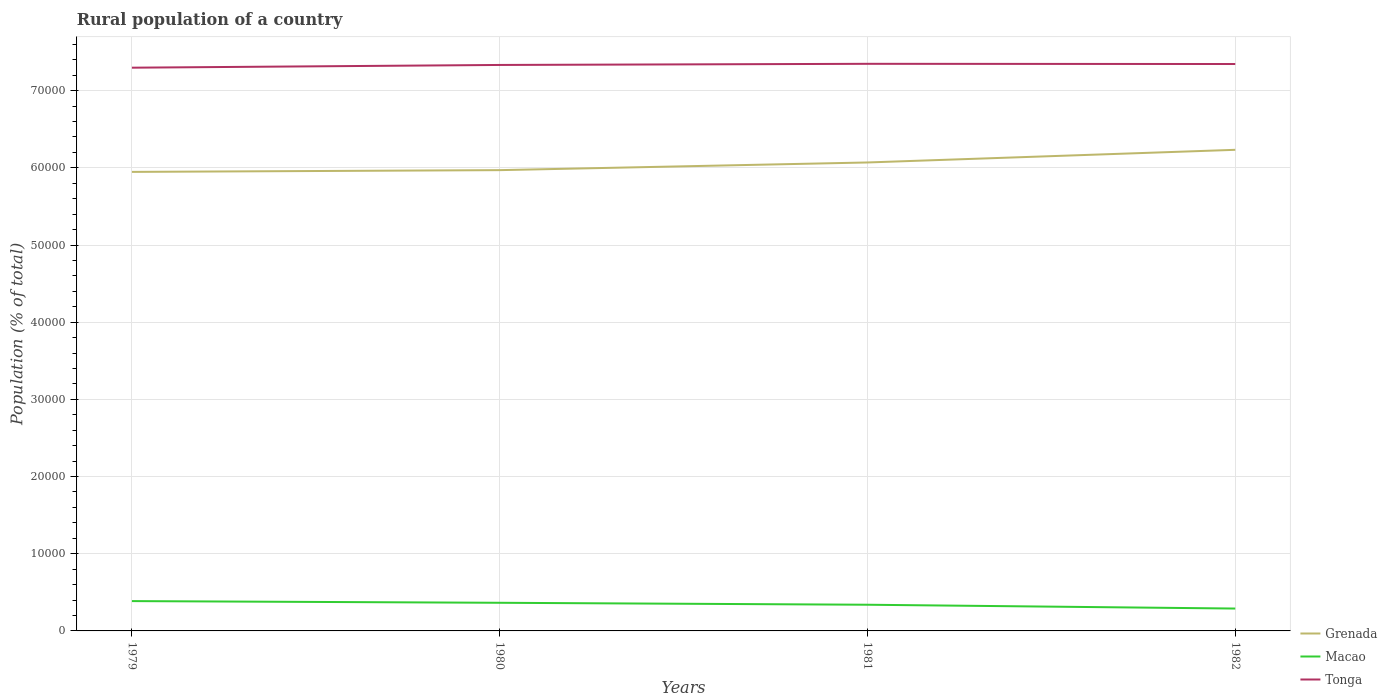Does the line corresponding to Macao intersect with the line corresponding to Tonga?
Provide a short and direct response. No. Is the number of lines equal to the number of legend labels?
Your response must be concise. Yes. Across all years, what is the maximum rural population in Grenada?
Provide a short and direct response. 5.95e+04. In which year was the rural population in Grenada maximum?
Your answer should be compact. 1979. What is the total rural population in Tonga in the graph?
Offer a terse response. -477. What is the difference between the highest and the second highest rural population in Grenada?
Your response must be concise. 2862. Does the graph contain grids?
Keep it short and to the point. Yes. Where does the legend appear in the graph?
Give a very brief answer. Bottom right. What is the title of the graph?
Provide a succinct answer. Rural population of a country. Does "Mongolia" appear as one of the legend labels in the graph?
Your answer should be compact. No. What is the label or title of the Y-axis?
Your answer should be very brief. Population (% of total). What is the Population (% of total) of Grenada in 1979?
Ensure brevity in your answer.  5.95e+04. What is the Population (% of total) of Macao in 1979?
Provide a short and direct response. 3865. What is the Population (% of total) in Tonga in 1979?
Your answer should be very brief. 7.30e+04. What is the Population (% of total) in Grenada in 1980?
Provide a succinct answer. 5.97e+04. What is the Population (% of total) in Macao in 1980?
Provide a short and direct response. 3647. What is the Population (% of total) of Tonga in 1980?
Give a very brief answer. 7.33e+04. What is the Population (% of total) of Grenada in 1981?
Your answer should be very brief. 6.07e+04. What is the Population (% of total) of Macao in 1981?
Your response must be concise. 3393. What is the Population (% of total) in Tonga in 1981?
Offer a very short reply. 7.35e+04. What is the Population (% of total) of Grenada in 1982?
Offer a very short reply. 6.23e+04. What is the Population (% of total) in Macao in 1982?
Your answer should be compact. 2899. What is the Population (% of total) in Tonga in 1982?
Offer a terse response. 7.35e+04. Across all years, what is the maximum Population (% of total) in Grenada?
Provide a succinct answer. 6.23e+04. Across all years, what is the maximum Population (% of total) of Macao?
Ensure brevity in your answer.  3865. Across all years, what is the maximum Population (% of total) in Tonga?
Offer a very short reply. 7.35e+04. Across all years, what is the minimum Population (% of total) of Grenada?
Offer a terse response. 5.95e+04. Across all years, what is the minimum Population (% of total) of Macao?
Make the answer very short. 2899. Across all years, what is the minimum Population (% of total) of Tonga?
Give a very brief answer. 7.30e+04. What is the total Population (% of total) of Grenada in the graph?
Provide a succinct answer. 2.42e+05. What is the total Population (% of total) of Macao in the graph?
Your answer should be compact. 1.38e+04. What is the total Population (% of total) in Tonga in the graph?
Ensure brevity in your answer.  2.93e+05. What is the difference between the Population (% of total) in Grenada in 1979 and that in 1980?
Provide a short and direct response. -228. What is the difference between the Population (% of total) of Macao in 1979 and that in 1980?
Provide a succinct answer. 218. What is the difference between the Population (% of total) in Tonga in 1979 and that in 1980?
Ensure brevity in your answer.  -356. What is the difference between the Population (% of total) in Grenada in 1979 and that in 1981?
Offer a terse response. -1221. What is the difference between the Population (% of total) in Macao in 1979 and that in 1981?
Provide a succinct answer. 472. What is the difference between the Population (% of total) of Tonga in 1979 and that in 1981?
Make the answer very short. -503. What is the difference between the Population (% of total) of Grenada in 1979 and that in 1982?
Offer a terse response. -2862. What is the difference between the Population (% of total) in Macao in 1979 and that in 1982?
Offer a terse response. 966. What is the difference between the Population (% of total) in Tonga in 1979 and that in 1982?
Offer a terse response. -477. What is the difference between the Population (% of total) in Grenada in 1980 and that in 1981?
Keep it short and to the point. -993. What is the difference between the Population (% of total) in Macao in 1980 and that in 1981?
Provide a succinct answer. 254. What is the difference between the Population (% of total) of Tonga in 1980 and that in 1981?
Make the answer very short. -147. What is the difference between the Population (% of total) in Grenada in 1980 and that in 1982?
Your answer should be compact. -2634. What is the difference between the Population (% of total) in Macao in 1980 and that in 1982?
Provide a succinct answer. 748. What is the difference between the Population (% of total) in Tonga in 1980 and that in 1982?
Your answer should be compact. -121. What is the difference between the Population (% of total) of Grenada in 1981 and that in 1982?
Your answer should be compact. -1641. What is the difference between the Population (% of total) of Macao in 1981 and that in 1982?
Your answer should be very brief. 494. What is the difference between the Population (% of total) of Tonga in 1981 and that in 1982?
Give a very brief answer. 26. What is the difference between the Population (% of total) in Grenada in 1979 and the Population (% of total) in Macao in 1980?
Your answer should be very brief. 5.58e+04. What is the difference between the Population (% of total) of Grenada in 1979 and the Population (% of total) of Tonga in 1980?
Give a very brief answer. -1.39e+04. What is the difference between the Population (% of total) of Macao in 1979 and the Population (% of total) of Tonga in 1980?
Offer a terse response. -6.95e+04. What is the difference between the Population (% of total) in Grenada in 1979 and the Population (% of total) in Macao in 1981?
Your answer should be compact. 5.61e+04. What is the difference between the Population (% of total) in Grenada in 1979 and the Population (% of total) in Tonga in 1981?
Offer a terse response. -1.40e+04. What is the difference between the Population (% of total) of Macao in 1979 and the Population (% of total) of Tonga in 1981?
Offer a terse response. -6.96e+04. What is the difference between the Population (% of total) of Grenada in 1979 and the Population (% of total) of Macao in 1982?
Offer a terse response. 5.66e+04. What is the difference between the Population (% of total) of Grenada in 1979 and the Population (% of total) of Tonga in 1982?
Your response must be concise. -1.40e+04. What is the difference between the Population (% of total) of Macao in 1979 and the Population (% of total) of Tonga in 1982?
Give a very brief answer. -6.96e+04. What is the difference between the Population (% of total) of Grenada in 1980 and the Population (% of total) of Macao in 1981?
Provide a succinct answer. 5.63e+04. What is the difference between the Population (% of total) of Grenada in 1980 and the Population (% of total) of Tonga in 1981?
Provide a short and direct response. -1.38e+04. What is the difference between the Population (% of total) of Macao in 1980 and the Population (% of total) of Tonga in 1981?
Your response must be concise. -6.98e+04. What is the difference between the Population (% of total) of Grenada in 1980 and the Population (% of total) of Macao in 1982?
Provide a short and direct response. 5.68e+04. What is the difference between the Population (% of total) of Grenada in 1980 and the Population (% of total) of Tonga in 1982?
Offer a very short reply. -1.38e+04. What is the difference between the Population (% of total) in Macao in 1980 and the Population (% of total) in Tonga in 1982?
Your response must be concise. -6.98e+04. What is the difference between the Population (% of total) in Grenada in 1981 and the Population (% of total) in Macao in 1982?
Make the answer very short. 5.78e+04. What is the difference between the Population (% of total) of Grenada in 1981 and the Population (% of total) of Tonga in 1982?
Your answer should be compact. -1.28e+04. What is the difference between the Population (% of total) in Macao in 1981 and the Population (% of total) in Tonga in 1982?
Make the answer very short. -7.01e+04. What is the average Population (% of total) of Grenada per year?
Offer a terse response. 6.06e+04. What is the average Population (% of total) in Macao per year?
Ensure brevity in your answer.  3451. What is the average Population (% of total) in Tonga per year?
Your answer should be compact. 7.33e+04. In the year 1979, what is the difference between the Population (% of total) in Grenada and Population (% of total) in Macao?
Offer a very short reply. 5.56e+04. In the year 1979, what is the difference between the Population (% of total) of Grenada and Population (% of total) of Tonga?
Provide a short and direct response. -1.35e+04. In the year 1979, what is the difference between the Population (% of total) in Macao and Population (% of total) in Tonga?
Your answer should be compact. -6.91e+04. In the year 1980, what is the difference between the Population (% of total) in Grenada and Population (% of total) in Macao?
Your answer should be very brief. 5.61e+04. In the year 1980, what is the difference between the Population (% of total) of Grenada and Population (% of total) of Tonga?
Make the answer very short. -1.36e+04. In the year 1980, what is the difference between the Population (% of total) in Macao and Population (% of total) in Tonga?
Your answer should be very brief. -6.97e+04. In the year 1981, what is the difference between the Population (% of total) in Grenada and Population (% of total) in Macao?
Offer a terse response. 5.73e+04. In the year 1981, what is the difference between the Population (% of total) in Grenada and Population (% of total) in Tonga?
Keep it short and to the point. -1.28e+04. In the year 1981, what is the difference between the Population (% of total) in Macao and Population (% of total) in Tonga?
Offer a very short reply. -7.01e+04. In the year 1982, what is the difference between the Population (% of total) in Grenada and Population (% of total) in Macao?
Your answer should be very brief. 5.94e+04. In the year 1982, what is the difference between the Population (% of total) of Grenada and Population (% of total) of Tonga?
Give a very brief answer. -1.11e+04. In the year 1982, what is the difference between the Population (% of total) in Macao and Population (% of total) in Tonga?
Your answer should be compact. -7.06e+04. What is the ratio of the Population (% of total) of Grenada in 1979 to that in 1980?
Your answer should be compact. 1. What is the ratio of the Population (% of total) of Macao in 1979 to that in 1980?
Make the answer very short. 1.06. What is the ratio of the Population (% of total) in Tonga in 1979 to that in 1980?
Ensure brevity in your answer.  1. What is the ratio of the Population (% of total) of Grenada in 1979 to that in 1981?
Give a very brief answer. 0.98. What is the ratio of the Population (% of total) in Macao in 1979 to that in 1981?
Provide a succinct answer. 1.14. What is the ratio of the Population (% of total) in Tonga in 1979 to that in 1981?
Your answer should be very brief. 0.99. What is the ratio of the Population (% of total) of Grenada in 1979 to that in 1982?
Provide a short and direct response. 0.95. What is the ratio of the Population (% of total) of Macao in 1979 to that in 1982?
Your answer should be very brief. 1.33. What is the ratio of the Population (% of total) in Tonga in 1979 to that in 1982?
Offer a very short reply. 0.99. What is the ratio of the Population (% of total) in Grenada in 1980 to that in 1981?
Provide a succinct answer. 0.98. What is the ratio of the Population (% of total) in Macao in 1980 to that in 1981?
Offer a terse response. 1.07. What is the ratio of the Population (% of total) of Tonga in 1980 to that in 1981?
Keep it short and to the point. 1. What is the ratio of the Population (% of total) of Grenada in 1980 to that in 1982?
Provide a succinct answer. 0.96. What is the ratio of the Population (% of total) of Macao in 1980 to that in 1982?
Your response must be concise. 1.26. What is the ratio of the Population (% of total) in Tonga in 1980 to that in 1982?
Offer a very short reply. 1. What is the ratio of the Population (% of total) of Grenada in 1981 to that in 1982?
Your response must be concise. 0.97. What is the ratio of the Population (% of total) in Macao in 1981 to that in 1982?
Make the answer very short. 1.17. What is the ratio of the Population (% of total) in Tonga in 1981 to that in 1982?
Provide a short and direct response. 1. What is the difference between the highest and the second highest Population (% of total) in Grenada?
Provide a succinct answer. 1641. What is the difference between the highest and the second highest Population (% of total) of Macao?
Give a very brief answer. 218. What is the difference between the highest and the second highest Population (% of total) of Tonga?
Make the answer very short. 26. What is the difference between the highest and the lowest Population (% of total) of Grenada?
Provide a succinct answer. 2862. What is the difference between the highest and the lowest Population (% of total) of Macao?
Offer a very short reply. 966. What is the difference between the highest and the lowest Population (% of total) of Tonga?
Ensure brevity in your answer.  503. 